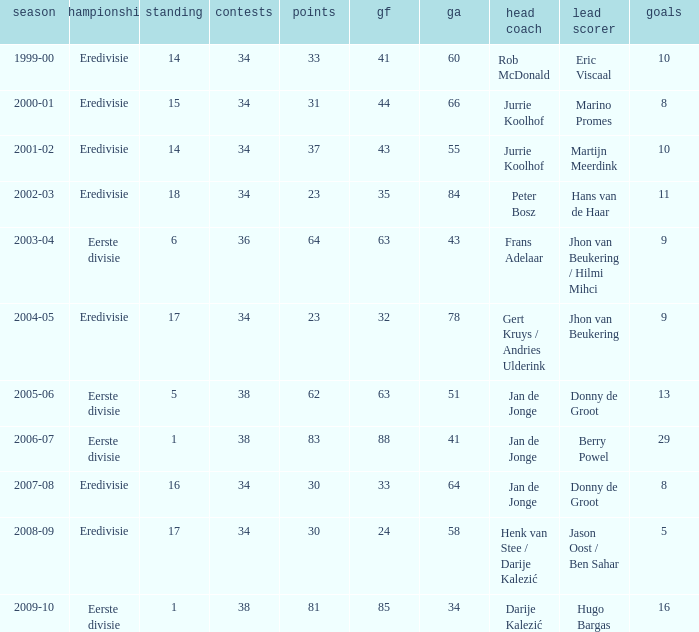Would you be able to parse every entry in this table? {'header': ['season', 'championship', 'standing', 'contests', 'points', 'gf', 'ga', 'head coach', 'lead scorer', 'goals'], 'rows': [['1999-00', 'Eredivisie', '14', '34', '33', '41', '60', 'Rob McDonald', 'Eric Viscaal', '10'], ['2000-01', 'Eredivisie', '15', '34', '31', '44', '66', 'Jurrie Koolhof', 'Marino Promes', '8'], ['2001-02', 'Eredivisie', '14', '34', '37', '43', '55', 'Jurrie Koolhof', 'Martijn Meerdink', '10'], ['2002-03', 'Eredivisie', '18', '34', '23', '35', '84', 'Peter Bosz', 'Hans van de Haar', '11'], ['2003-04', 'Eerste divisie', '6', '36', '64', '63', '43', 'Frans Adelaar', 'Jhon van Beukering / Hilmi Mihci', '9'], ['2004-05', 'Eredivisie', '17', '34', '23', '32', '78', 'Gert Kruys / Andries Ulderink', 'Jhon van Beukering', '9'], ['2005-06', 'Eerste divisie', '5', '38', '62', '63', '51', 'Jan de Jonge', 'Donny de Groot', '13'], ['2006-07', 'Eerste divisie', '1', '38', '83', '88', '41', 'Jan de Jonge', 'Berry Powel', '29'], ['2007-08', 'Eredivisie', '16', '34', '30', '33', '64', 'Jan de Jonge', 'Donny de Groot', '8'], ['2008-09', 'Eredivisie', '17', '34', '30', '24', '58', 'Henk van Stee / Darije Kalezić', 'Jason Oost / Ben Sahar', '5'], ['2009-10', 'Eerste divisie', '1', '38', '81', '85', '34', 'Darije Kalezić', 'Hugo Bargas', '16']]} Who is the top scorer where gf is 41? Eric Viscaal. 